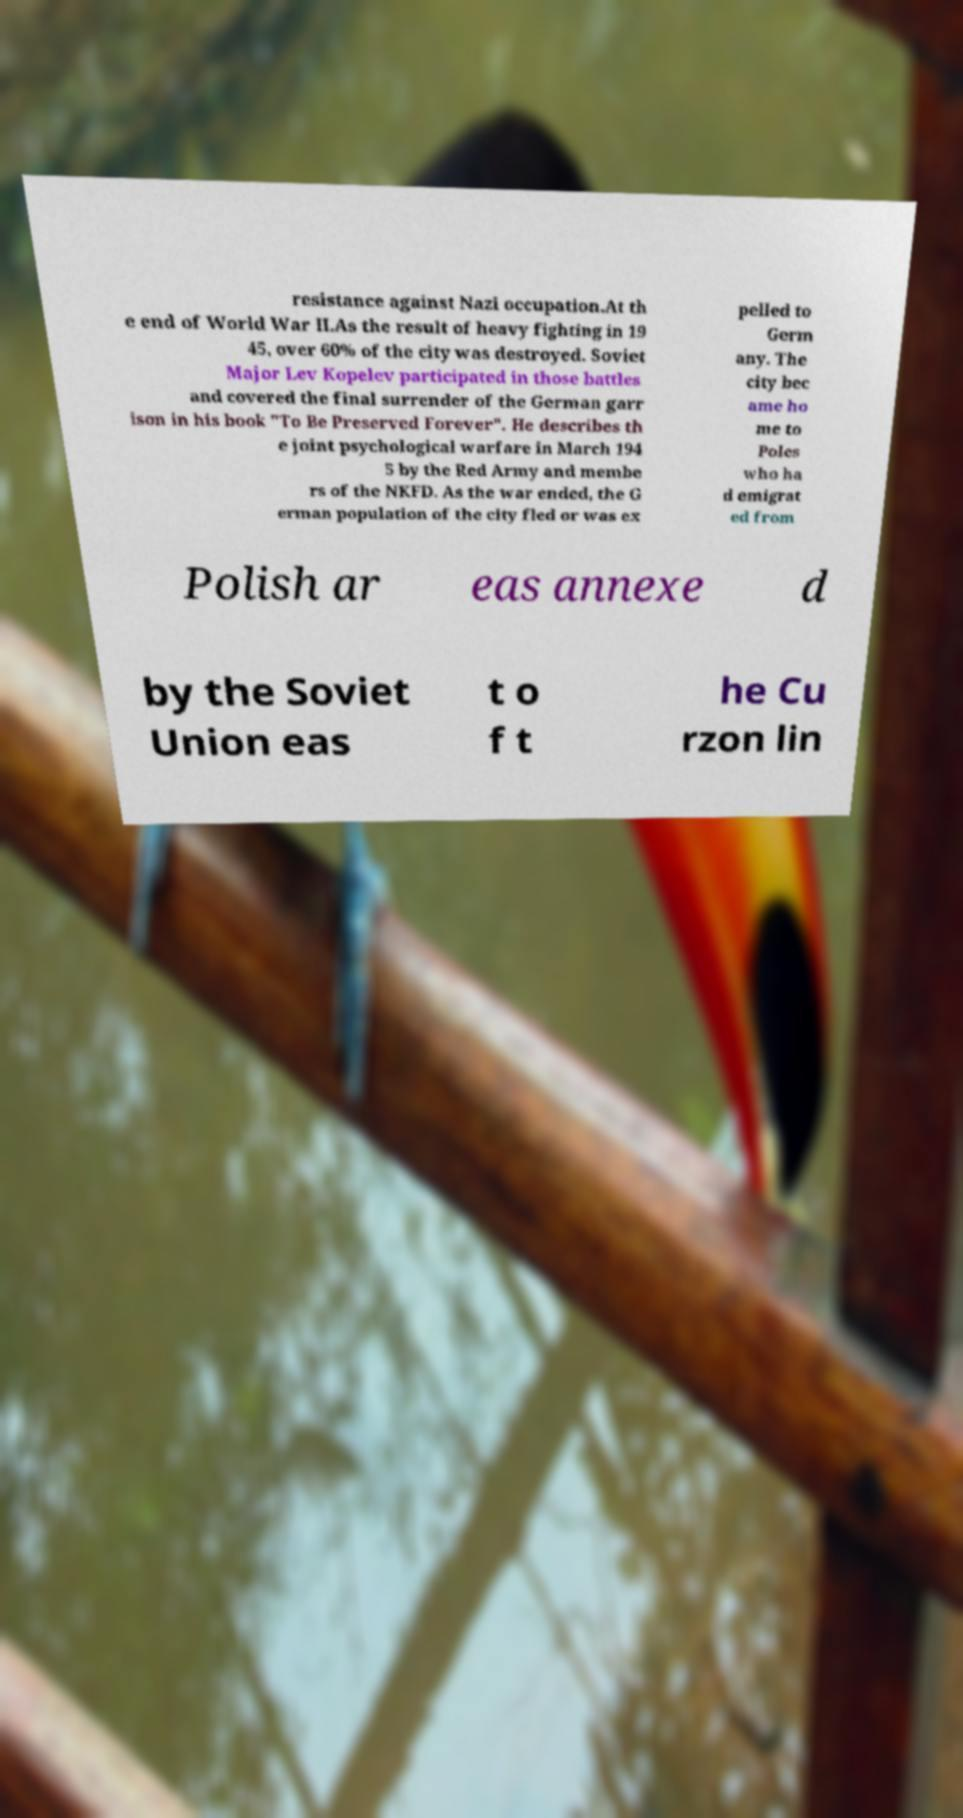Can you accurately transcribe the text from the provided image for me? resistance against Nazi occupation.At th e end of World War II.As the result of heavy fighting in 19 45, over 60% of the city was destroyed. Soviet Major Lev Kopelev participated in those battles and covered the final surrender of the German garr ison in his book "To Be Preserved Forever". He describes th e joint psychological warfare in March 194 5 by the Red Army and membe rs of the NKFD. As the war ended, the G erman population of the city fled or was ex pelled to Germ any. The city bec ame ho me to Poles who ha d emigrat ed from Polish ar eas annexe d by the Soviet Union eas t o f t he Cu rzon lin 